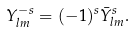Convert formula to latex. <formula><loc_0><loc_0><loc_500><loc_500>Y ^ { - s } _ { l m } = ( - 1 ) ^ { s } \bar { Y } ^ { s } _ { l m } .</formula> 